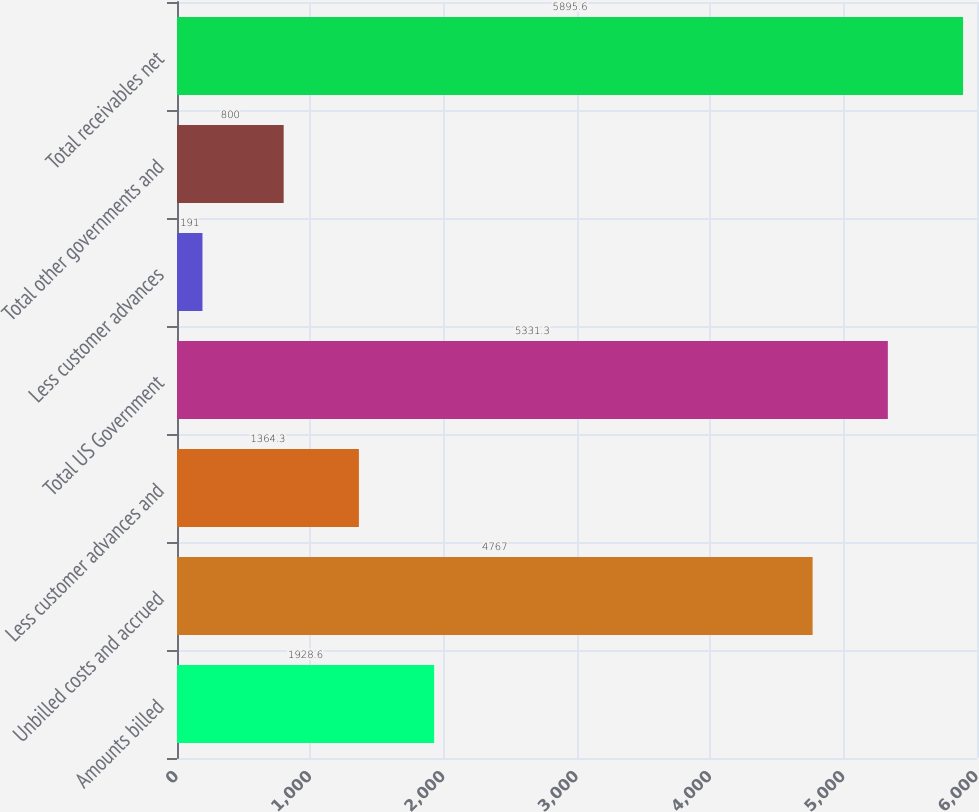Convert chart to OTSL. <chart><loc_0><loc_0><loc_500><loc_500><bar_chart><fcel>Amounts billed<fcel>Unbilled costs and accrued<fcel>Less customer advances and<fcel>Total US Government<fcel>Less customer advances<fcel>Total other governments and<fcel>Total receivables net<nl><fcel>1928.6<fcel>4767<fcel>1364.3<fcel>5331.3<fcel>191<fcel>800<fcel>5895.6<nl></chart> 